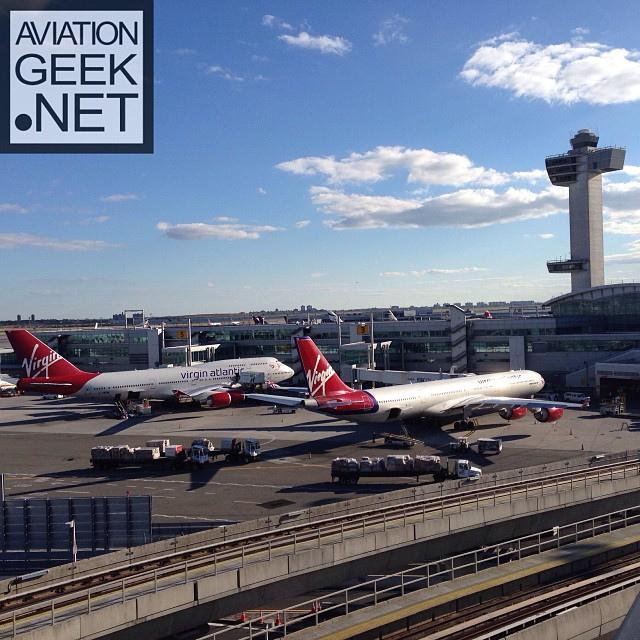What other item did the company whose name appears on the large vehicle make? Please explain your reasoning. phones. They also have phones. 